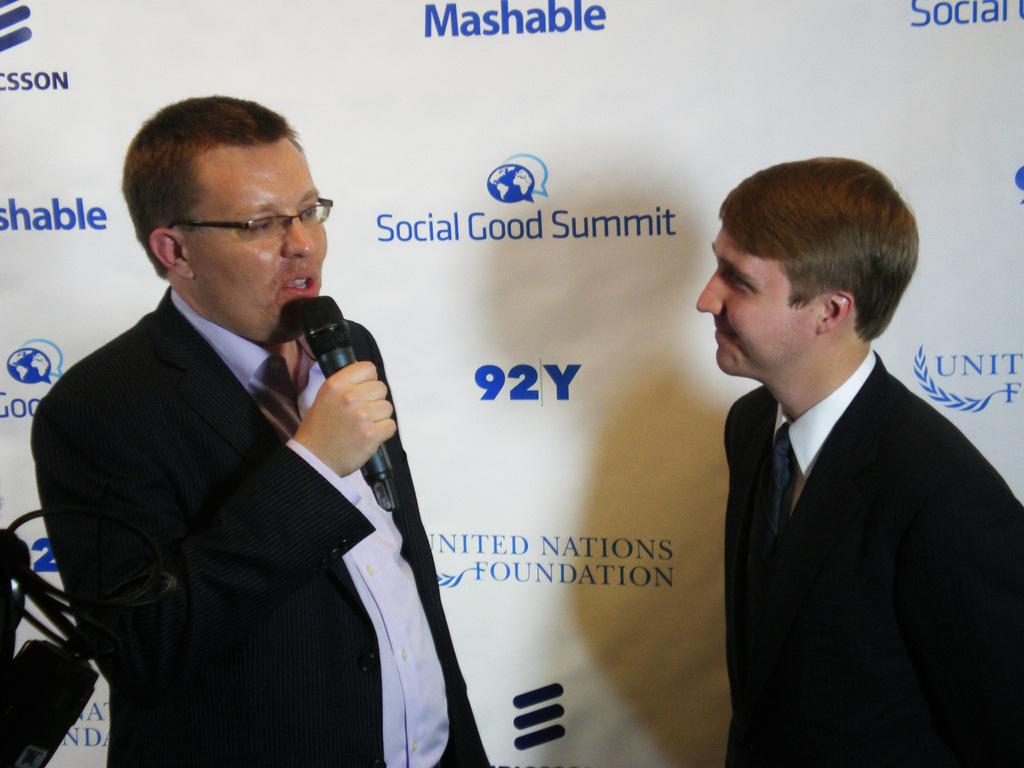How many people are visible in the image? There are two people standing on a path in the image. What is the man holding in the image? The man is holding a microphone in the image. What can be seen behind the people in the image? There is a banner behind the people in the image. What is the price of the show being advertised on the banner? There is no information about a show or its price on the banner in the image. 